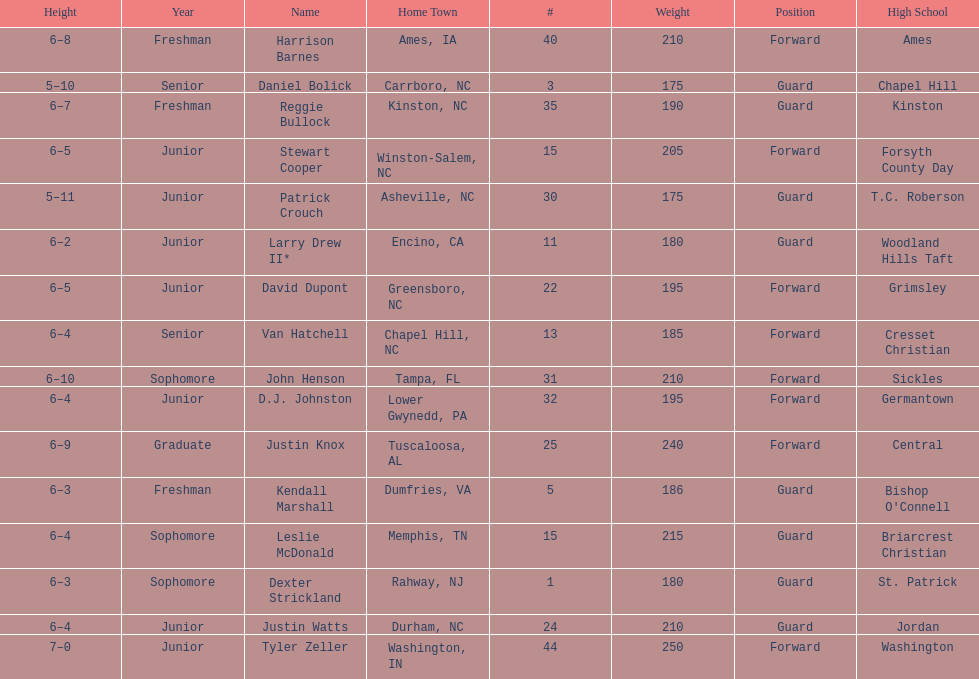What is the number of players with a weight over 200? 7. 